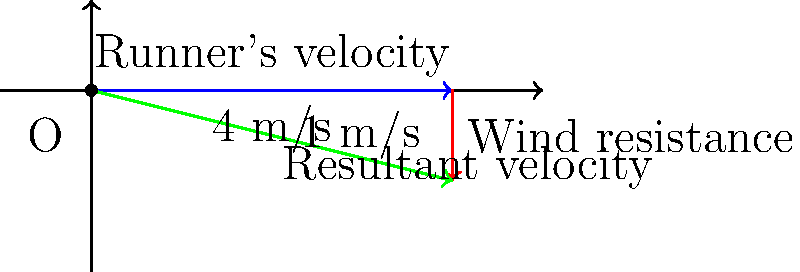In a cross-country race, an underdog runner is maintaining a steady pace of 4 m/s eastward. Suddenly, they encounter a headwind with a velocity of 1 m/s westward. Using the vector addition diagram provided, calculate the runner's resultant velocity. How might this affect their performance in the race? Let's break this down step-by-step:

1) The runner's initial velocity is represented by the blue vector, which is 4 m/s eastward. In vector notation, this is $\vec{v}_1 = (4, 0)$ m/s.

2) The wind resistance is represented by the red vector, which is 1 m/s westward. In vector notation, this is $\vec{v}_2 = (-1, 0)$ m/s.

3) To find the resultant velocity, we need to add these vectors:
   $\vec{v}_{\text{resultant}} = \vec{v}_1 + \vec{v}_2 = (4, 0) + (-1, 0) = (3, 0)$ m/s

4) The green vector in the diagram represents this resultant velocity.

5) The magnitude of the resultant velocity is 3 m/s eastward.

Impact on performance:
The headwind has reduced the runner's velocity from 4 m/s to 3 m/s, a 25% reduction. This significant slowdown could negatively impact the underdog's performance, potentially allowing other runners to catch up or increase their lead. However, if the underdog is particularly skilled at maintaining form in windy conditions, they might be able to minimize the impact and use this challenge to showcase their resilience.
Answer: 3 m/s eastward 